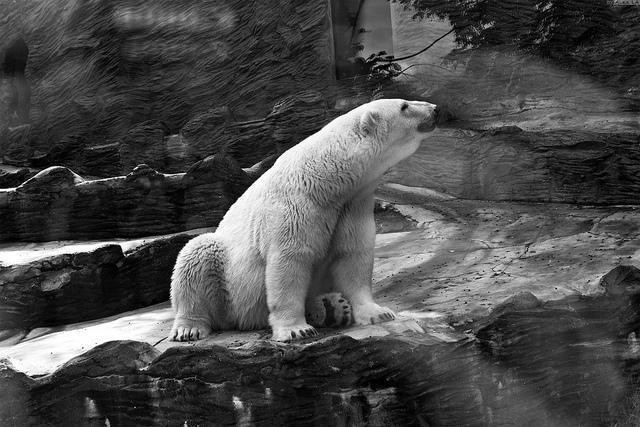How many people are floating in water?
Give a very brief answer. 0. 